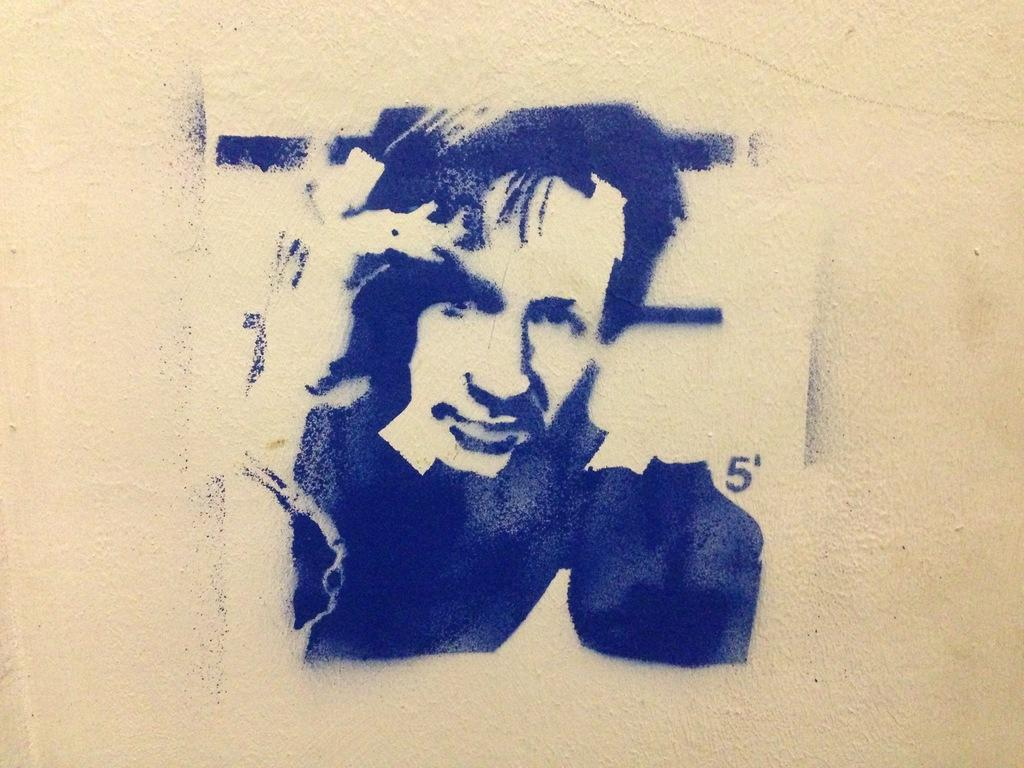What can be seen in the image? There is a wall in the image. What is on the wall? There is graffiti on the wall. What type of toothbrush is being used to write the graffiti on the wall? There is no toothbrush present in the image, and the graffiti is not being written with a toothbrush. 